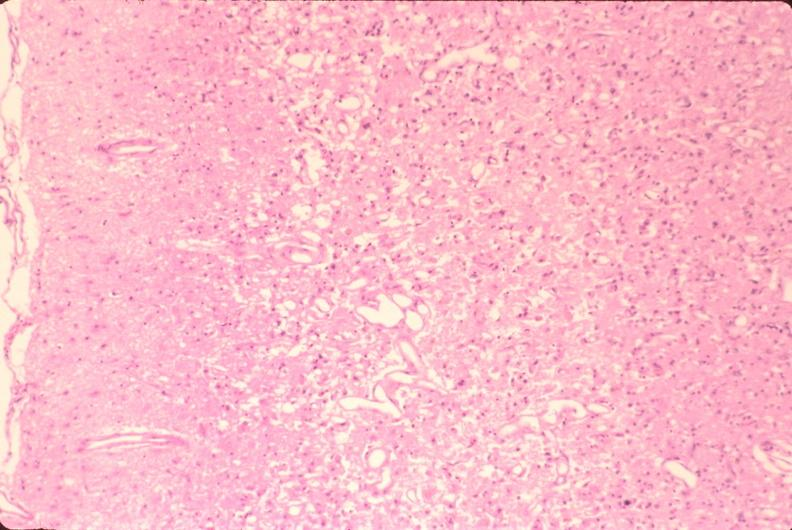s nervous present?
Answer the question using a single word or phrase. Yes 